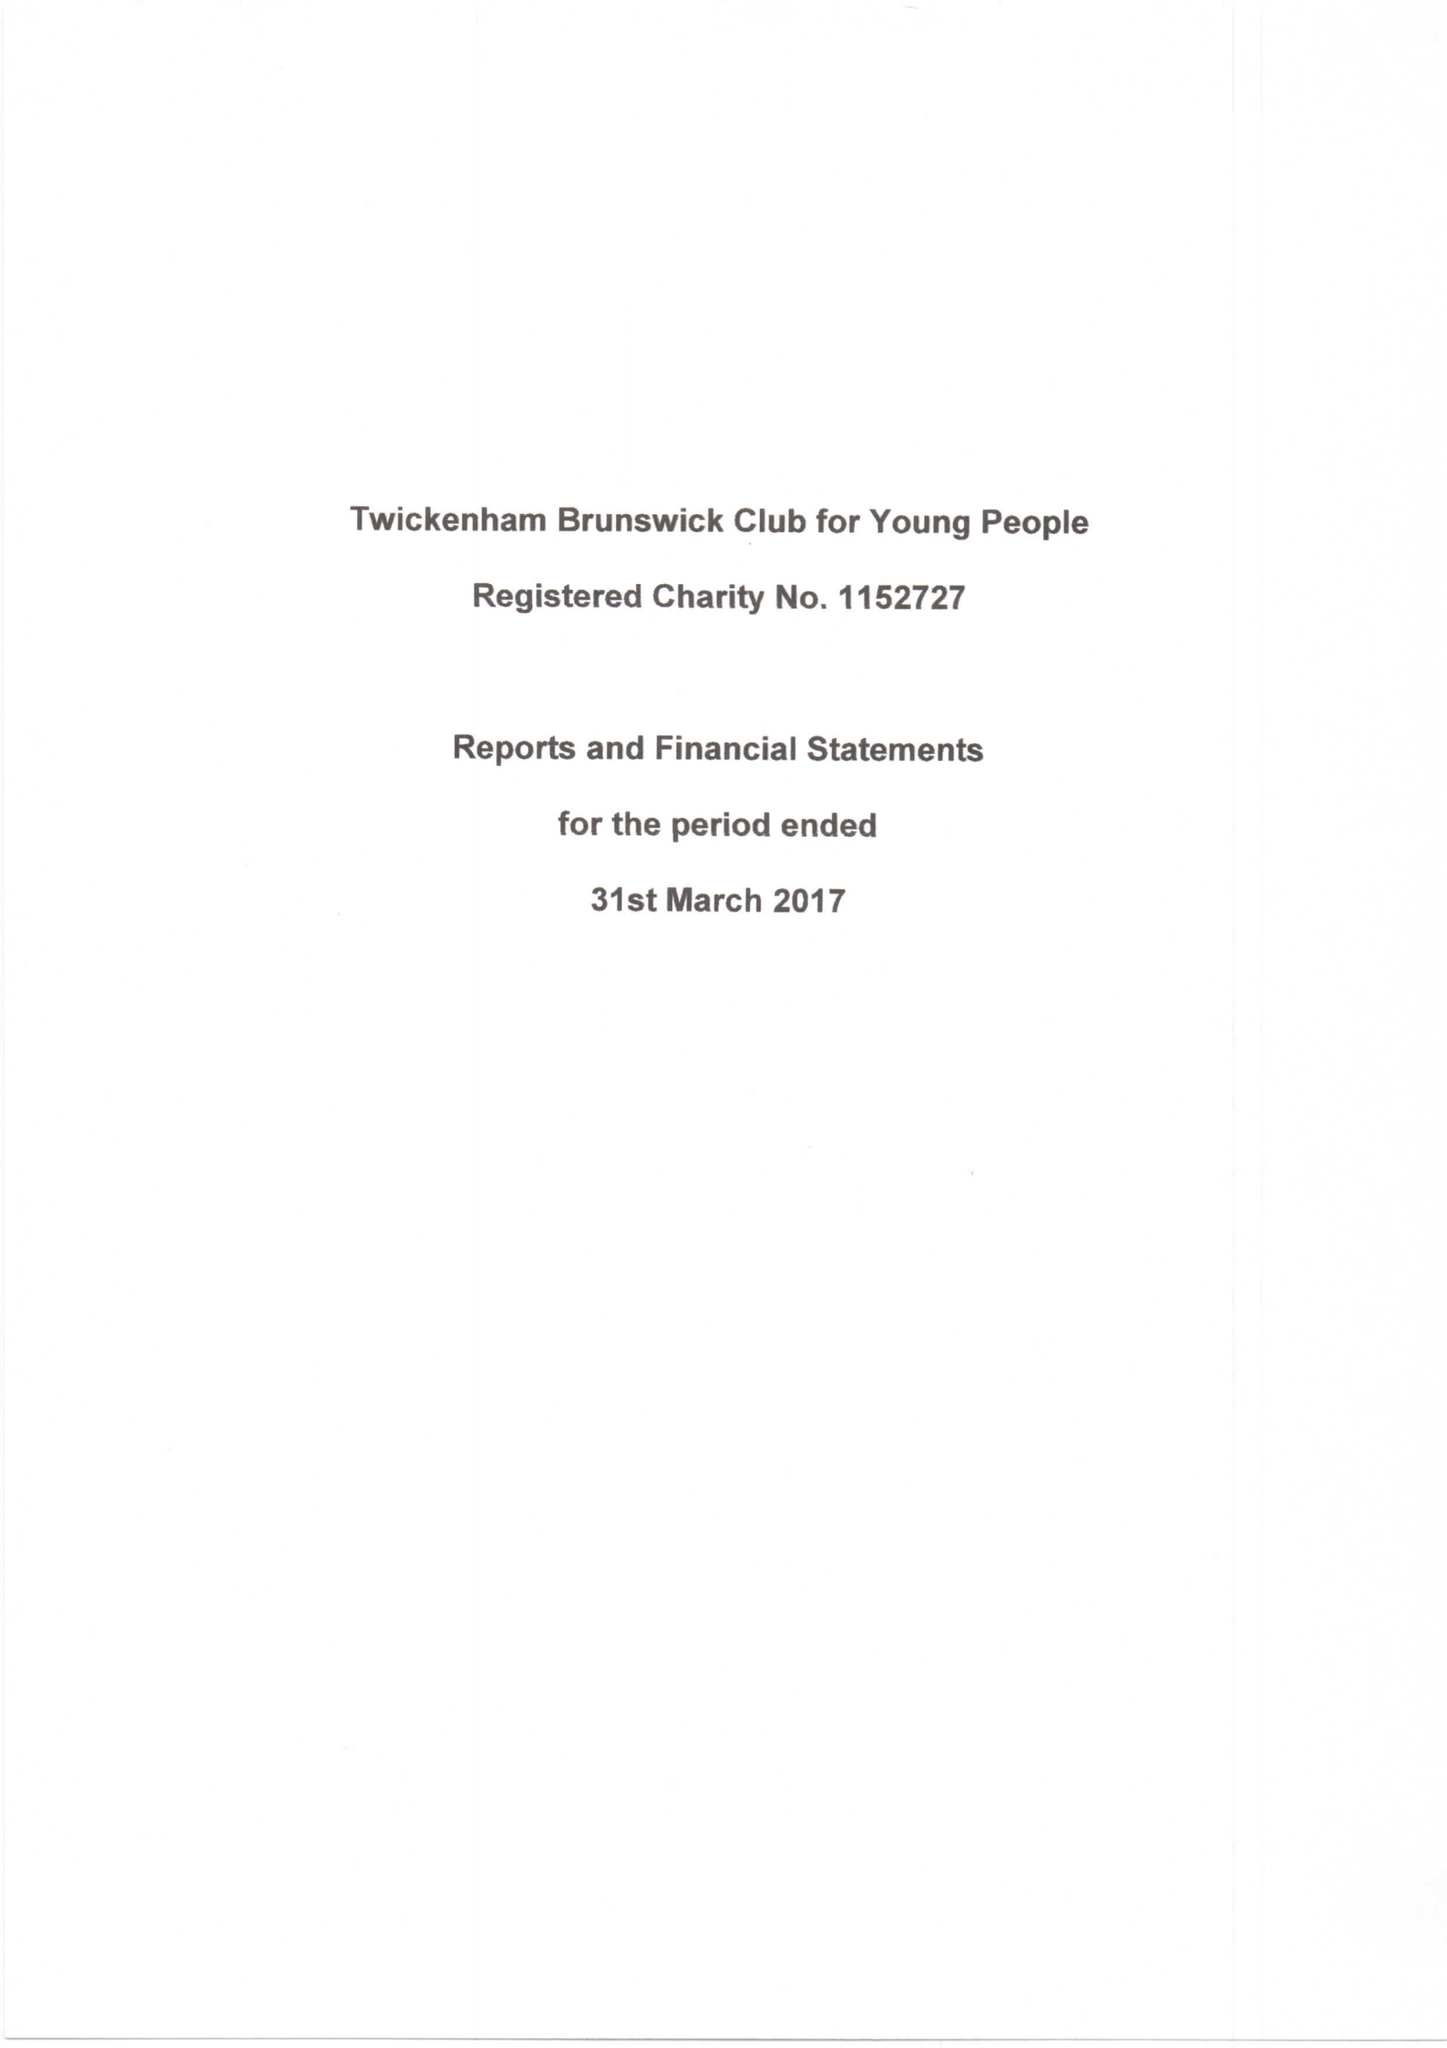What is the value for the report_date?
Answer the question using a single word or phrase. 2017-03-31 